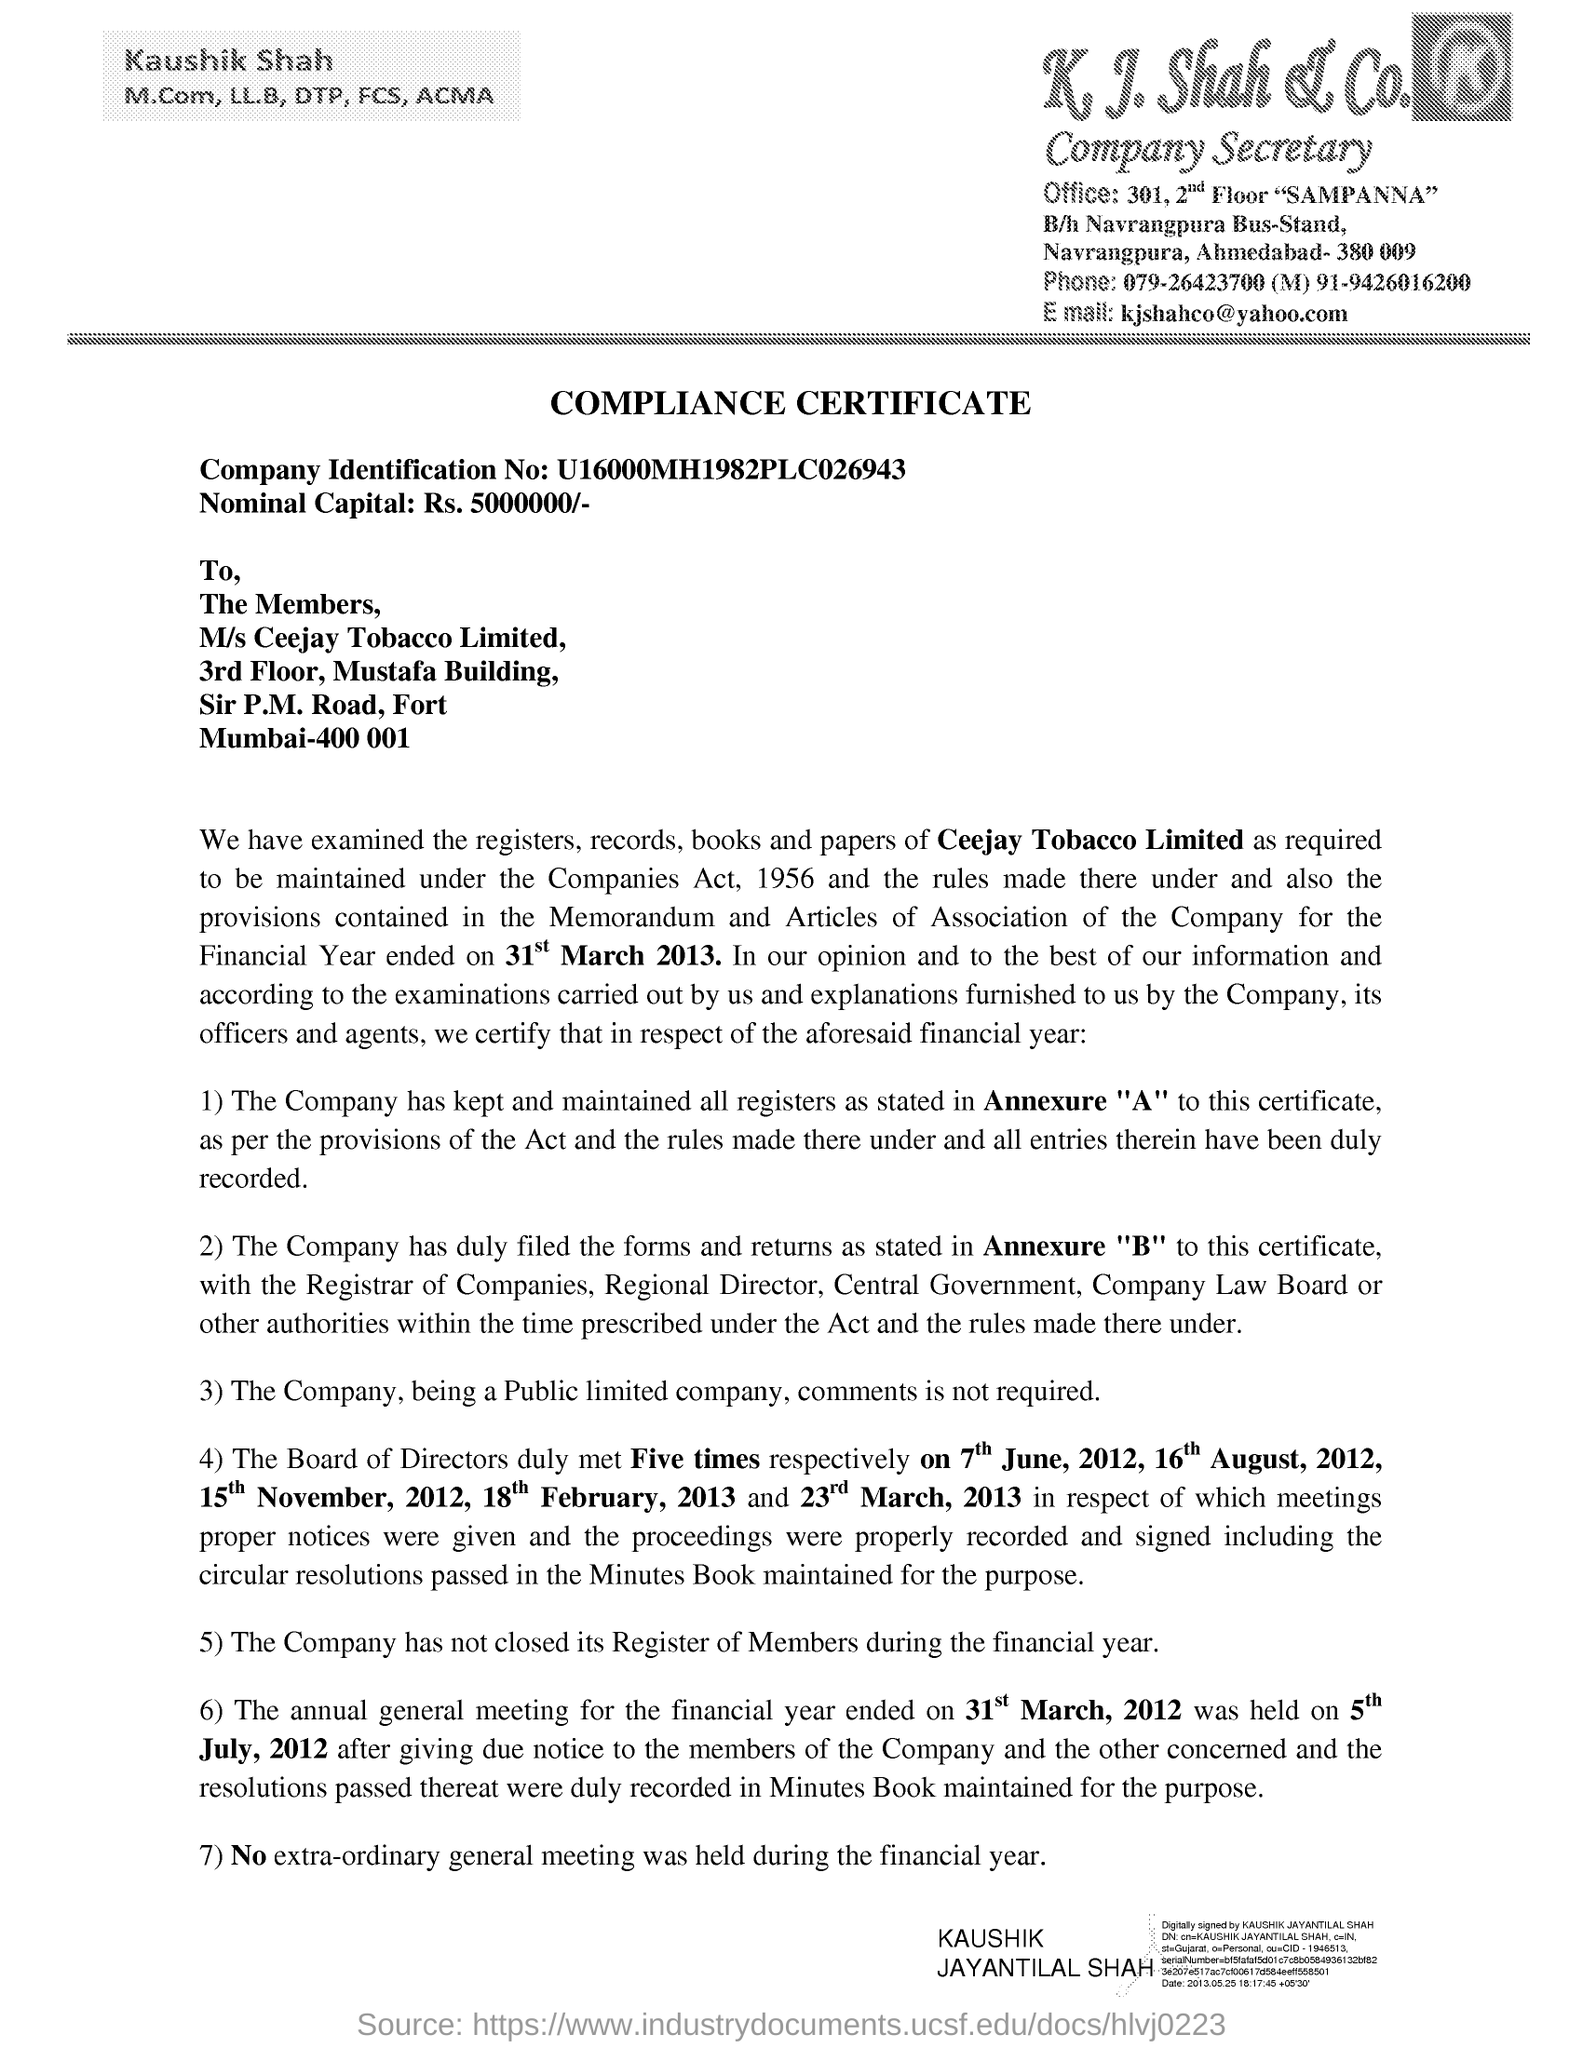What's the significance of the nominal capital mentioned? The nominal capital, stated as Rs. 5000000 in the document, represents the total value of shares that the company is authorized to issue. This amount is a key figure in corporate finance, impacting the company's ability to raise funds and its financial stability. 